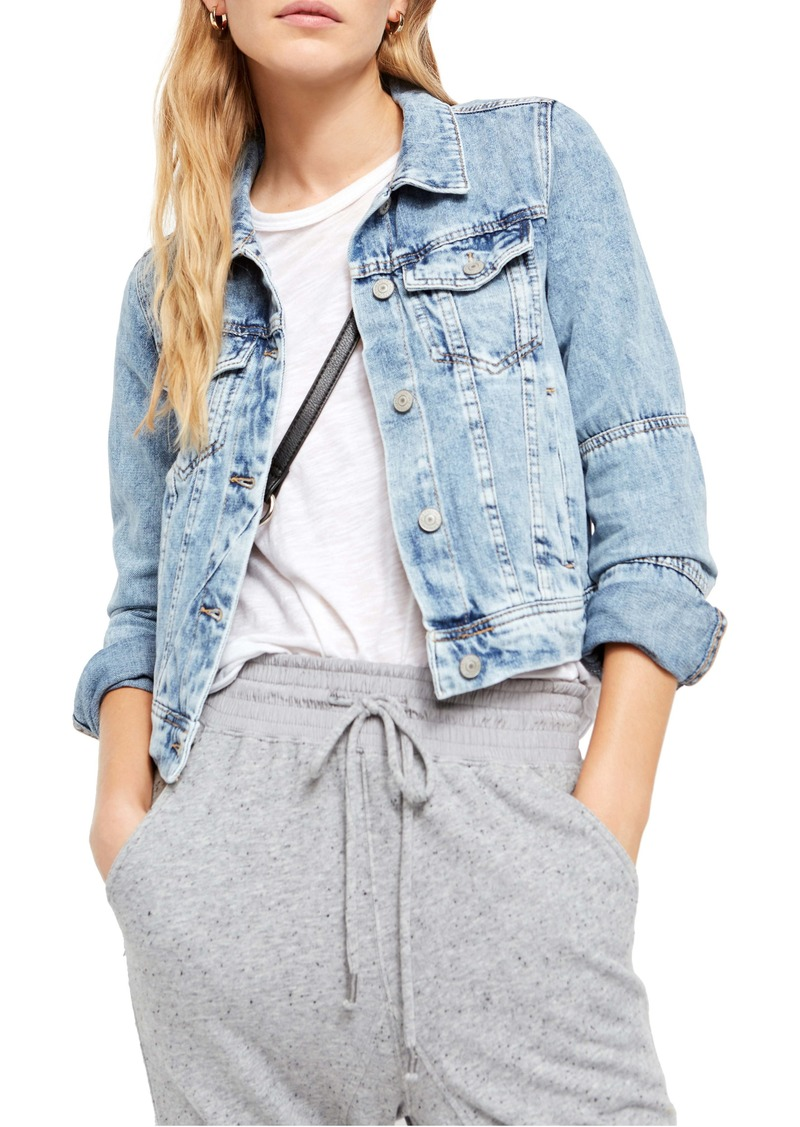How does the choice of accessories complement the overall style of the outfit? The choice of a small black cross-body bag complements the outfit by adding a sleek, functional accessory that enhances the laid-back yet put-together aesthetic. It is practical without overpowering the simplicity of the outfit, providing just enough contrast to the light-colored top and matching nicely with the casual theme of the ensemble. 